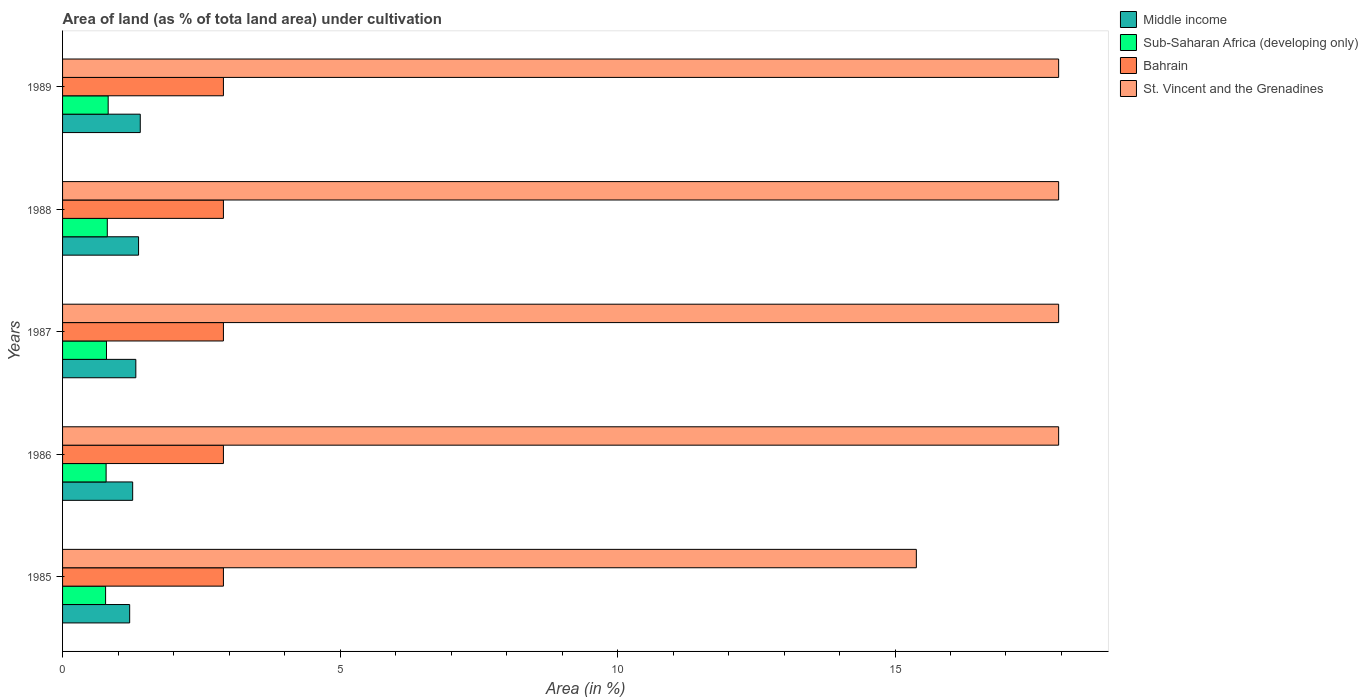How many different coloured bars are there?
Offer a very short reply. 4. How many groups of bars are there?
Your response must be concise. 5. Are the number of bars per tick equal to the number of legend labels?
Make the answer very short. Yes. Are the number of bars on each tick of the Y-axis equal?
Offer a terse response. Yes. How many bars are there on the 2nd tick from the bottom?
Your answer should be compact. 4. What is the label of the 5th group of bars from the top?
Offer a very short reply. 1985. What is the percentage of land under cultivation in Bahrain in 1987?
Your response must be concise. 2.9. Across all years, what is the maximum percentage of land under cultivation in St. Vincent and the Grenadines?
Keep it short and to the point. 17.95. Across all years, what is the minimum percentage of land under cultivation in Middle income?
Your response must be concise. 1.21. In which year was the percentage of land under cultivation in St. Vincent and the Grenadines maximum?
Offer a very short reply. 1986. What is the total percentage of land under cultivation in Middle income in the graph?
Your answer should be very brief. 6.56. What is the difference between the percentage of land under cultivation in Middle income in 1987 and that in 1988?
Offer a terse response. -0.05. What is the difference between the percentage of land under cultivation in St. Vincent and the Grenadines in 1985 and the percentage of land under cultivation in Bahrain in 1989?
Your answer should be compact. 12.49. What is the average percentage of land under cultivation in St. Vincent and the Grenadines per year?
Keep it short and to the point. 17.44. In the year 1987, what is the difference between the percentage of land under cultivation in Bahrain and percentage of land under cultivation in Middle income?
Ensure brevity in your answer.  1.58. What is the ratio of the percentage of land under cultivation in Sub-Saharan Africa (developing only) in 1986 to that in 1989?
Your answer should be very brief. 0.95. Is the percentage of land under cultivation in Bahrain in 1987 less than that in 1988?
Provide a succinct answer. No. Is the difference between the percentage of land under cultivation in Bahrain in 1986 and 1988 greater than the difference between the percentage of land under cultivation in Middle income in 1986 and 1988?
Keep it short and to the point. Yes. What is the difference between the highest and the lowest percentage of land under cultivation in Bahrain?
Keep it short and to the point. 0. Is the sum of the percentage of land under cultivation in Middle income in 1985 and 1989 greater than the maximum percentage of land under cultivation in Bahrain across all years?
Your answer should be compact. No. Is it the case that in every year, the sum of the percentage of land under cultivation in St. Vincent and the Grenadines and percentage of land under cultivation in Bahrain is greater than the sum of percentage of land under cultivation in Sub-Saharan Africa (developing only) and percentage of land under cultivation in Middle income?
Offer a terse response. Yes. What does the 4th bar from the top in 1985 represents?
Keep it short and to the point. Middle income. What does the 3rd bar from the bottom in 1985 represents?
Your answer should be compact. Bahrain. Is it the case that in every year, the sum of the percentage of land under cultivation in Sub-Saharan Africa (developing only) and percentage of land under cultivation in Middle income is greater than the percentage of land under cultivation in St. Vincent and the Grenadines?
Ensure brevity in your answer.  No. How many bars are there?
Your response must be concise. 20. Are all the bars in the graph horizontal?
Make the answer very short. Yes. How many years are there in the graph?
Ensure brevity in your answer.  5. What is the difference between two consecutive major ticks on the X-axis?
Keep it short and to the point. 5. Are the values on the major ticks of X-axis written in scientific E-notation?
Keep it short and to the point. No. Does the graph contain grids?
Offer a very short reply. No. Where does the legend appear in the graph?
Provide a succinct answer. Top right. How are the legend labels stacked?
Make the answer very short. Vertical. What is the title of the graph?
Ensure brevity in your answer.  Area of land (as % of tota land area) under cultivation. What is the label or title of the X-axis?
Offer a terse response. Area (in %). What is the label or title of the Y-axis?
Make the answer very short. Years. What is the Area (in %) in Middle income in 1985?
Ensure brevity in your answer.  1.21. What is the Area (in %) of Sub-Saharan Africa (developing only) in 1985?
Keep it short and to the point. 0.78. What is the Area (in %) in Bahrain in 1985?
Give a very brief answer. 2.9. What is the Area (in %) in St. Vincent and the Grenadines in 1985?
Make the answer very short. 15.38. What is the Area (in %) of Middle income in 1986?
Provide a succinct answer. 1.26. What is the Area (in %) in Sub-Saharan Africa (developing only) in 1986?
Provide a short and direct response. 0.78. What is the Area (in %) in Bahrain in 1986?
Give a very brief answer. 2.9. What is the Area (in %) of St. Vincent and the Grenadines in 1986?
Provide a succinct answer. 17.95. What is the Area (in %) in Middle income in 1987?
Provide a short and direct response. 1.32. What is the Area (in %) in Sub-Saharan Africa (developing only) in 1987?
Provide a succinct answer. 0.79. What is the Area (in %) in Bahrain in 1987?
Provide a succinct answer. 2.9. What is the Area (in %) of St. Vincent and the Grenadines in 1987?
Give a very brief answer. 17.95. What is the Area (in %) in Middle income in 1988?
Make the answer very short. 1.37. What is the Area (in %) in Sub-Saharan Africa (developing only) in 1988?
Your answer should be very brief. 0.81. What is the Area (in %) in Bahrain in 1988?
Your response must be concise. 2.9. What is the Area (in %) of St. Vincent and the Grenadines in 1988?
Make the answer very short. 17.95. What is the Area (in %) in Middle income in 1989?
Ensure brevity in your answer.  1.4. What is the Area (in %) of Sub-Saharan Africa (developing only) in 1989?
Offer a very short reply. 0.82. What is the Area (in %) in Bahrain in 1989?
Make the answer very short. 2.9. What is the Area (in %) of St. Vincent and the Grenadines in 1989?
Give a very brief answer. 17.95. Across all years, what is the maximum Area (in %) in Middle income?
Provide a succinct answer. 1.4. Across all years, what is the maximum Area (in %) in Sub-Saharan Africa (developing only)?
Make the answer very short. 0.82. Across all years, what is the maximum Area (in %) in Bahrain?
Your response must be concise. 2.9. Across all years, what is the maximum Area (in %) of St. Vincent and the Grenadines?
Provide a short and direct response. 17.95. Across all years, what is the minimum Area (in %) of Middle income?
Ensure brevity in your answer.  1.21. Across all years, what is the minimum Area (in %) of Sub-Saharan Africa (developing only)?
Your response must be concise. 0.78. Across all years, what is the minimum Area (in %) of Bahrain?
Provide a succinct answer. 2.9. Across all years, what is the minimum Area (in %) in St. Vincent and the Grenadines?
Offer a very short reply. 15.38. What is the total Area (in %) of Middle income in the graph?
Your answer should be very brief. 6.56. What is the total Area (in %) of Sub-Saharan Africa (developing only) in the graph?
Your response must be concise. 3.98. What is the total Area (in %) of Bahrain in the graph?
Provide a succinct answer. 14.49. What is the total Area (in %) of St. Vincent and the Grenadines in the graph?
Your answer should be very brief. 87.18. What is the difference between the Area (in %) in Middle income in 1985 and that in 1986?
Ensure brevity in your answer.  -0.05. What is the difference between the Area (in %) in Sub-Saharan Africa (developing only) in 1985 and that in 1986?
Keep it short and to the point. -0.01. What is the difference between the Area (in %) in St. Vincent and the Grenadines in 1985 and that in 1986?
Provide a short and direct response. -2.56. What is the difference between the Area (in %) in Middle income in 1985 and that in 1987?
Give a very brief answer. -0.11. What is the difference between the Area (in %) in Sub-Saharan Africa (developing only) in 1985 and that in 1987?
Ensure brevity in your answer.  -0.02. What is the difference between the Area (in %) of St. Vincent and the Grenadines in 1985 and that in 1987?
Your answer should be compact. -2.56. What is the difference between the Area (in %) of Middle income in 1985 and that in 1988?
Make the answer very short. -0.16. What is the difference between the Area (in %) of Sub-Saharan Africa (developing only) in 1985 and that in 1988?
Your answer should be very brief. -0.03. What is the difference between the Area (in %) in Bahrain in 1985 and that in 1988?
Your answer should be very brief. 0. What is the difference between the Area (in %) in St. Vincent and the Grenadines in 1985 and that in 1988?
Offer a very short reply. -2.56. What is the difference between the Area (in %) in Middle income in 1985 and that in 1989?
Your answer should be very brief. -0.19. What is the difference between the Area (in %) of Sub-Saharan Africa (developing only) in 1985 and that in 1989?
Offer a terse response. -0.05. What is the difference between the Area (in %) in St. Vincent and the Grenadines in 1985 and that in 1989?
Your response must be concise. -2.56. What is the difference between the Area (in %) in Middle income in 1986 and that in 1987?
Make the answer very short. -0.06. What is the difference between the Area (in %) in Sub-Saharan Africa (developing only) in 1986 and that in 1987?
Offer a terse response. -0.01. What is the difference between the Area (in %) in Bahrain in 1986 and that in 1987?
Keep it short and to the point. 0. What is the difference between the Area (in %) in St. Vincent and the Grenadines in 1986 and that in 1987?
Provide a short and direct response. 0. What is the difference between the Area (in %) of Middle income in 1986 and that in 1988?
Offer a very short reply. -0.11. What is the difference between the Area (in %) of Sub-Saharan Africa (developing only) in 1986 and that in 1988?
Make the answer very short. -0.02. What is the difference between the Area (in %) in Bahrain in 1986 and that in 1988?
Your answer should be compact. 0. What is the difference between the Area (in %) in Middle income in 1986 and that in 1989?
Your response must be concise. -0.14. What is the difference between the Area (in %) in Sub-Saharan Africa (developing only) in 1986 and that in 1989?
Keep it short and to the point. -0.04. What is the difference between the Area (in %) in Middle income in 1987 and that in 1988?
Offer a terse response. -0.05. What is the difference between the Area (in %) in Sub-Saharan Africa (developing only) in 1987 and that in 1988?
Make the answer very short. -0.01. What is the difference between the Area (in %) in Bahrain in 1987 and that in 1988?
Make the answer very short. 0. What is the difference between the Area (in %) of St. Vincent and the Grenadines in 1987 and that in 1988?
Give a very brief answer. 0. What is the difference between the Area (in %) of Middle income in 1987 and that in 1989?
Give a very brief answer. -0.08. What is the difference between the Area (in %) of Sub-Saharan Africa (developing only) in 1987 and that in 1989?
Keep it short and to the point. -0.03. What is the difference between the Area (in %) in St. Vincent and the Grenadines in 1987 and that in 1989?
Your response must be concise. 0. What is the difference between the Area (in %) of Middle income in 1988 and that in 1989?
Offer a very short reply. -0.03. What is the difference between the Area (in %) in Sub-Saharan Africa (developing only) in 1988 and that in 1989?
Give a very brief answer. -0.02. What is the difference between the Area (in %) in Bahrain in 1988 and that in 1989?
Keep it short and to the point. 0. What is the difference between the Area (in %) in St. Vincent and the Grenadines in 1988 and that in 1989?
Keep it short and to the point. 0. What is the difference between the Area (in %) in Middle income in 1985 and the Area (in %) in Sub-Saharan Africa (developing only) in 1986?
Your answer should be compact. 0.42. What is the difference between the Area (in %) of Middle income in 1985 and the Area (in %) of Bahrain in 1986?
Your answer should be compact. -1.69. What is the difference between the Area (in %) of Middle income in 1985 and the Area (in %) of St. Vincent and the Grenadines in 1986?
Provide a short and direct response. -16.74. What is the difference between the Area (in %) of Sub-Saharan Africa (developing only) in 1985 and the Area (in %) of Bahrain in 1986?
Provide a short and direct response. -2.12. What is the difference between the Area (in %) of Sub-Saharan Africa (developing only) in 1985 and the Area (in %) of St. Vincent and the Grenadines in 1986?
Offer a terse response. -17.17. What is the difference between the Area (in %) of Bahrain in 1985 and the Area (in %) of St. Vincent and the Grenadines in 1986?
Offer a terse response. -15.05. What is the difference between the Area (in %) of Middle income in 1985 and the Area (in %) of Sub-Saharan Africa (developing only) in 1987?
Ensure brevity in your answer.  0.42. What is the difference between the Area (in %) of Middle income in 1985 and the Area (in %) of Bahrain in 1987?
Offer a very short reply. -1.69. What is the difference between the Area (in %) of Middle income in 1985 and the Area (in %) of St. Vincent and the Grenadines in 1987?
Your answer should be very brief. -16.74. What is the difference between the Area (in %) in Sub-Saharan Africa (developing only) in 1985 and the Area (in %) in Bahrain in 1987?
Your answer should be very brief. -2.12. What is the difference between the Area (in %) in Sub-Saharan Africa (developing only) in 1985 and the Area (in %) in St. Vincent and the Grenadines in 1987?
Your answer should be very brief. -17.17. What is the difference between the Area (in %) in Bahrain in 1985 and the Area (in %) in St. Vincent and the Grenadines in 1987?
Ensure brevity in your answer.  -15.05. What is the difference between the Area (in %) in Middle income in 1985 and the Area (in %) in Sub-Saharan Africa (developing only) in 1988?
Ensure brevity in your answer.  0.4. What is the difference between the Area (in %) in Middle income in 1985 and the Area (in %) in Bahrain in 1988?
Your response must be concise. -1.69. What is the difference between the Area (in %) in Middle income in 1985 and the Area (in %) in St. Vincent and the Grenadines in 1988?
Provide a succinct answer. -16.74. What is the difference between the Area (in %) in Sub-Saharan Africa (developing only) in 1985 and the Area (in %) in Bahrain in 1988?
Provide a succinct answer. -2.12. What is the difference between the Area (in %) of Sub-Saharan Africa (developing only) in 1985 and the Area (in %) of St. Vincent and the Grenadines in 1988?
Make the answer very short. -17.17. What is the difference between the Area (in %) in Bahrain in 1985 and the Area (in %) in St. Vincent and the Grenadines in 1988?
Offer a very short reply. -15.05. What is the difference between the Area (in %) in Middle income in 1985 and the Area (in %) in Sub-Saharan Africa (developing only) in 1989?
Ensure brevity in your answer.  0.39. What is the difference between the Area (in %) of Middle income in 1985 and the Area (in %) of Bahrain in 1989?
Give a very brief answer. -1.69. What is the difference between the Area (in %) in Middle income in 1985 and the Area (in %) in St. Vincent and the Grenadines in 1989?
Give a very brief answer. -16.74. What is the difference between the Area (in %) of Sub-Saharan Africa (developing only) in 1985 and the Area (in %) of Bahrain in 1989?
Ensure brevity in your answer.  -2.12. What is the difference between the Area (in %) of Sub-Saharan Africa (developing only) in 1985 and the Area (in %) of St. Vincent and the Grenadines in 1989?
Make the answer very short. -17.17. What is the difference between the Area (in %) in Bahrain in 1985 and the Area (in %) in St. Vincent and the Grenadines in 1989?
Offer a very short reply. -15.05. What is the difference between the Area (in %) in Middle income in 1986 and the Area (in %) in Sub-Saharan Africa (developing only) in 1987?
Ensure brevity in your answer.  0.47. What is the difference between the Area (in %) of Middle income in 1986 and the Area (in %) of Bahrain in 1987?
Provide a short and direct response. -1.64. What is the difference between the Area (in %) in Middle income in 1986 and the Area (in %) in St. Vincent and the Grenadines in 1987?
Your answer should be very brief. -16.69. What is the difference between the Area (in %) in Sub-Saharan Africa (developing only) in 1986 and the Area (in %) in Bahrain in 1987?
Offer a terse response. -2.11. What is the difference between the Area (in %) of Sub-Saharan Africa (developing only) in 1986 and the Area (in %) of St. Vincent and the Grenadines in 1987?
Your answer should be very brief. -17.16. What is the difference between the Area (in %) in Bahrain in 1986 and the Area (in %) in St. Vincent and the Grenadines in 1987?
Provide a succinct answer. -15.05. What is the difference between the Area (in %) of Middle income in 1986 and the Area (in %) of Sub-Saharan Africa (developing only) in 1988?
Ensure brevity in your answer.  0.46. What is the difference between the Area (in %) in Middle income in 1986 and the Area (in %) in Bahrain in 1988?
Make the answer very short. -1.64. What is the difference between the Area (in %) in Middle income in 1986 and the Area (in %) in St. Vincent and the Grenadines in 1988?
Make the answer very short. -16.69. What is the difference between the Area (in %) of Sub-Saharan Africa (developing only) in 1986 and the Area (in %) of Bahrain in 1988?
Your answer should be compact. -2.11. What is the difference between the Area (in %) of Sub-Saharan Africa (developing only) in 1986 and the Area (in %) of St. Vincent and the Grenadines in 1988?
Provide a succinct answer. -17.16. What is the difference between the Area (in %) in Bahrain in 1986 and the Area (in %) in St. Vincent and the Grenadines in 1988?
Make the answer very short. -15.05. What is the difference between the Area (in %) of Middle income in 1986 and the Area (in %) of Sub-Saharan Africa (developing only) in 1989?
Provide a short and direct response. 0.44. What is the difference between the Area (in %) in Middle income in 1986 and the Area (in %) in Bahrain in 1989?
Provide a succinct answer. -1.64. What is the difference between the Area (in %) in Middle income in 1986 and the Area (in %) in St. Vincent and the Grenadines in 1989?
Keep it short and to the point. -16.69. What is the difference between the Area (in %) of Sub-Saharan Africa (developing only) in 1986 and the Area (in %) of Bahrain in 1989?
Provide a short and direct response. -2.11. What is the difference between the Area (in %) of Sub-Saharan Africa (developing only) in 1986 and the Area (in %) of St. Vincent and the Grenadines in 1989?
Give a very brief answer. -17.16. What is the difference between the Area (in %) of Bahrain in 1986 and the Area (in %) of St. Vincent and the Grenadines in 1989?
Ensure brevity in your answer.  -15.05. What is the difference between the Area (in %) in Middle income in 1987 and the Area (in %) in Sub-Saharan Africa (developing only) in 1988?
Ensure brevity in your answer.  0.51. What is the difference between the Area (in %) in Middle income in 1987 and the Area (in %) in Bahrain in 1988?
Your response must be concise. -1.58. What is the difference between the Area (in %) of Middle income in 1987 and the Area (in %) of St. Vincent and the Grenadines in 1988?
Your response must be concise. -16.63. What is the difference between the Area (in %) in Sub-Saharan Africa (developing only) in 1987 and the Area (in %) in Bahrain in 1988?
Offer a very short reply. -2.11. What is the difference between the Area (in %) of Sub-Saharan Africa (developing only) in 1987 and the Area (in %) of St. Vincent and the Grenadines in 1988?
Your response must be concise. -17.16. What is the difference between the Area (in %) of Bahrain in 1987 and the Area (in %) of St. Vincent and the Grenadines in 1988?
Provide a short and direct response. -15.05. What is the difference between the Area (in %) in Middle income in 1987 and the Area (in %) in Sub-Saharan Africa (developing only) in 1989?
Your answer should be very brief. 0.5. What is the difference between the Area (in %) of Middle income in 1987 and the Area (in %) of Bahrain in 1989?
Make the answer very short. -1.58. What is the difference between the Area (in %) of Middle income in 1987 and the Area (in %) of St. Vincent and the Grenadines in 1989?
Provide a short and direct response. -16.63. What is the difference between the Area (in %) of Sub-Saharan Africa (developing only) in 1987 and the Area (in %) of Bahrain in 1989?
Offer a very short reply. -2.11. What is the difference between the Area (in %) in Sub-Saharan Africa (developing only) in 1987 and the Area (in %) in St. Vincent and the Grenadines in 1989?
Your response must be concise. -17.16. What is the difference between the Area (in %) of Bahrain in 1987 and the Area (in %) of St. Vincent and the Grenadines in 1989?
Ensure brevity in your answer.  -15.05. What is the difference between the Area (in %) in Middle income in 1988 and the Area (in %) in Sub-Saharan Africa (developing only) in 1989?
Keep it short and to the point. 0.55. What is the difference between the Area (in %) of Middle income in 1988 and the Area (in %) of Bahrain in 1989?
Offer a terse response. -1.53. What is the difference between the Area (in %) in Middle income in 1988 and the Area (in %) in St. Vincent and the Grenadines in 1989?
Make the answer very short. -16.58. What is the difference between the Area (in %) in Sub-Saharan Africa (developing only) in 1988 and the Area (in %) in Bahrain in 1989?
Offer a terse response. -2.09. What is the difference between the Area (in %) of Sub-Saharan Africa (developing only) in 1988 and the Area (in %) of St. Vincent and the Grenadines in 1989?
Provide a succinct answer. -17.14. What is the difference between the Area (in %) of Bahrain in 1988 and the Area (in %) of St. Vincent and the Grenadines in 1989?
Your answer should be very brief. -15.05. What is the average Area (in %) in Middle income per year?
Give a very brief answer. 1.31. What is the average Area (in %) in Sub-Saharan Africa (developing only) per year?
Offer a very short reply. 0.8. What is the average Area (in %) of Bahrain per year?
Keep it short and to the point. 2.9. What is the average Area (in %) in St. Vincent and the Grenadines per year?
Your answer should be very brief. 17.44. In the year 1985, what is the difference between the Area (in %) of Middle income and Area (in %) of Sub-Saharan Africa (developing only)?
Your answer should be compact. 0.43. In the year 1985, what is the difference between the Area (in %) of Middle income and Area (in %) of Bahrain?
Your answer should be very brief. -1.69. In the year 1985, what is the difference between the Area (in %) of Middle income and Area (in %) of St. Vincent and the Grenadines?
Provide a succinct answer. -14.18. In the year 1985, what is the difference between the Area (in %) of Sub-Saharan Africa (developing only) and Area (in %) of Bahrain?
Ensure brevity in your answer.  -2.12. In the year 1985, what is the difference between the Area (in %) of Sub-Saharan Africa (developing only) and Area (in %) of St. Vincent and the Grenadines?
Provide a succinct answer. -14.61. In the year 1985, what is the difference between the Area (in %) in Bahrain and Area (in %) in St. Vincent and the Grenadines?
Provide a short and direct response. -12.49. In the year 1986, what is the difference between the Area (in %) in Middle income and Area (in %) in Sub-Saharan Africa (developing only)?
Your response must be concise. 0.48. In the year 1986, what is the difference between the Area (in %) of Middle income and Area (in %) of Bahrain?
Offer a terse response. -1.64. In the year 1986, what is the difference between the Area (in %) in Middle income and Area (in %) in St. Vincent and the Grenadines?
Your response must be concise. -16.69. In the year 1986, what is the difference between the Area (in %) of Sub-Saharan Africa (developing only) and Area (in %) of Bahrain?
Offer a terse response. -2.11. In the year 1986, what is the difference between the Area (in %) in Sub-Saharan Africa (developing only) and Area (in %) in St. Vincent and the Grenadines?
Provide a short and direct response. -17.16. In the year 1986, what is the difference between the Area (in %) of Bahrain and Area (in %) of St. Vincent and the Grenadines?
Keep it short and to the point. -15.05. In the year 1987, what is the difference between the Area (in %) of Middle income and Area (in %) of Sub-Saharan Africa (developing only)?
Your response must be concise. 0.53. In the year 1987, what is the difference between the Area (in %) in Middle income and Area (in %) in Bahrain?
Provide a succinct answer. -1.58. In the year 1987, what is the difference between the Area (in %) in Middle income and Area (in %) in St. Vincent and the Grenadines?
Offer a terse response. -16.63. In the year 1987, what is the difference between the Area (in %) in Sub-Saharan Africa (developing only) and Area (in %) in Bahrain?
Provide a succinct answer. -2.11. In the year 1987, what is the difference between the Area (in %) of Sub-Saharan Africa (developing only) and Area (in %) of St. Vincent and the Grenadines?
Offer a terse response. -17.16. In the year 1987, what is the difference between the Area (in %) of Bahrain and Area (in %) of St. Vincent and the Grenadines?
Provide a short and direct response. -15.05. In the year 1988, what is the difference between the Area (in %) in Middle income and Area (in %) in Sub-Saharan Africa (developing only)?
Offer a very short reply. 0.56. In the year 1988, what is the difference between the Area (in %) in Middle income and Area (in %) in Bahrain?
Give a very brief answer. -1.53. In the year 1988, what is the difference between the Area (in %) of Middle income and Area (in %) of St. Vincent and the Grenadines?
Ensure brevity in your answer.  -16.58. In the year 1988, what is the difference between the Area (in %) in Sub-Saharan Africa (developing only) and Area (in %) in Bahrain?
Your response must be concise. -2.09. In the year 1988, what is the difference between the Area (in %) in Sub-Saharan Africa (developing only) and Area (in %) in St. Vincent and the Grenadines?
Keep it short and to the point. -17.14. In the year 1988, what is the difference between the Area (in %) in Bahrain and Area (in %) in St. Vincent and the Grenadines?
Your answer should be compact. -15.05. In the year 1989, what is the difference between the Area (in %) of Middle income and Area (in %) of Sub-Saharan Africa (developing only)?
Your answer should be compact. 0.58. In the year 1989, what is the difference between the Area (in %) of Middle income and Area (in %) of Bahrain?
Your answer should be very brief. -1.5. In the year 1989, what is the difference between the Area (in %) in Middle income and Area (in %) in St. Vincent and the Grenadines?
Offer a terse response. -16.55. In the year 1989, what is the difference between the Area (in %) of Sub-Saharan Africa (developing only) and Area (in %) of Bahrain?
Ensure brevity in your answer.  -2.08. In the year 1989, what is the difference between the Area (in %) of Sub-Saharan Africa (developing only) and Area (in %) of St. Vincent and the Grenadines?
Your answer should be very brief. -17.13. In the year 1989, what is the difference between the Area (in %) of Bahrain and Area (in %) of St. Vincent and the Grenadines?
Offer a very short reply. -15.05. What is the ratio of the Area (in %) of Middle income in 1985 to that in 1986?
Ensure brevity in your answer.  0.96. What is the ratio of the Area (in %) in Sub-Saharan Africa (developing only) in 1985 to that in 1986?
Ensure brevity in your answer.  0.99. What is the ratio of the Area (in %) in Bahrain in 1985 to that in 1986?
Give a very brief answer. 1. What is the ratio of the Area (in %) of St. Vincent and the Grenadines in 1985 to that in 1986?
Your answer should be very brief. 0.86. What is the ratio of the Area (in %) in Middle income in 1985 to that in 1987?
Your answer should be very brief. 0.92. What is the ratio of the Area (in %) of Sub-Saharan Africa (developing only) in 1985 to that in 1987?
Keep it short and to the point. 0.98. What is the ratio of the Area (in %) in St. Vincent and the Grenadines in 1985 to that in 1987?
Offer a terse response. 0.86. What is the ratio of the Area (in %) in Middle income in 1985 to that in 1988?
Provide a succinct answer. 0.88. What is the ratio of the Area (in %) in Sub-Saharan Africa (developing only) in 1985 to that in 1988?
Offer a very short reply. 0.96. What is the ratio of the Area (in %) in Bahrain in 1985 to that in 1988?
Offer a very short reply. 1. What is the ratio of the Area (in %) in Middle income in 1985 to that in 1989?
Provide a succinct answer. 0.86. What is the ratio of the Area (in %) in Sub-Saharan Africa (developing only) in 1985 to that in 1989?
Offer a terse response. 0.94. What is the ratio of the Area (in %) of Bahrain in 1985 to that in 1989?
Ensure brevity in your answer.  1. What is the ratio of the Area (in %) in St. Vincent and the Grenadines in 1986 to that in 1987?
Your response must be concise. 1. What is the ratio of the Area (in %) of Middle income in 1986 to that in 1988?
Your response must be concise. 0.92. What is the ratio of the Area (in %) of Sub-Saharan Africa (developing only) in 1986 to that in 1988?
Your answer should be compact. 0.97. What is the ratio of the Area (in %) of Middle income in 1986 to that in 1989?
Offer a terse response. 0.9. What is the ratio of the Area (in %) in Sub-Saharan Africa (developing only) in 1986 to that in 1989?
Your response must be concise. 0.95. What is the ratio of the Area (in %) in St. Vincent and the Grenadines in 1986 to that in 1989?
Provide a short and direct response. 1. What is the ratio of the Area (in %) in Sub-Saharan Africa (developing only) in 1987 to that in 1988?
Offer a terse response. 0.98. What is the ratio of the Area (in %) of Bahrain in 1987 to that in 1988?
Ensure brevity in your answer.  1. What is the ratio of the Area (in %) in St. Vincent and the Grenadines in 1987 to that in 1988?
Make the answer very short. 1. What is the ratio of the Area (in %) of Middle income in 1987 to that in 1989?
Keep it short and to the point. 0.94. What is the ratio of the Area (in %) of Sub-Saharan Africa (developing only) in 1987 to that in 1989?
Provide a succinct answer. 0.96. What is the ratio of the Area (in %) of Bahrain in 1987 to that in 1989?
Keep it short and to the point. 1. What is the ratio of the Area (in %) of St. Vincent and the Grenadines in 1987 to that in 1989?
Your answer should be very brief. 1. What is the ratio of the Area (in %) of Middle income in 1988 to that in 1989?
Provide a succinct answer. 0.98. What is the ratio of the Area (in %) in Sub-Saharan Africa (developing only) in 1988 to that in 1989?
Your answer should be compact. 0.98. What is the difference between the highest and the second highest Area (in %) in Middle income?
Offer a very short reply. 0.03. What is the difference between the highest and the second highest Area (in %) in Sub-Saharan Africa (developing only)?
Your answer should be compact. 0.02. What is the difference between the highest and the second highest Area (in %) in Bahrain?
Your response must be concise. 0. What is the difference between the highest and the second highest Area (in %) in St. Vincent and the Grenadines?
Make the answer very short. 0. What is the difference between the highest and the lowest Area (in %) of Middle income?
Offer a very short reply. 0.19. What is the difference between the highest and the lowest Area (in %) of Sub-Saharan Africa (developing only)?
Give a very brief answer. 0.05. What is the difference between the highest and the lowest Area (in %) in Bahrain?
Provide a short and direct response. 0. What is the difference between the highest and the lowest Area (in %) of St. Vincent and the Grenadines?
Your response must be concise. 2.56. 